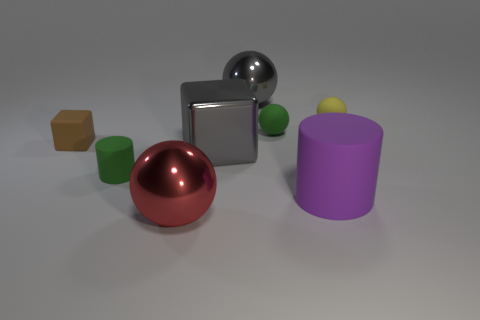Subtract 1 balls. How many balls are left? 3 Subtract all cyan balls. Subtract all green cubes. How many balls are left? 4 Add 1 big blue rubber cylinders. How many objects exist? 9 Subtract all blocks. How many objects are left? 6 Subtract 0 gray cylinders. How many objects are left? 8 Subtract all brown shiny balls. Subtract all yellow rubber things. How many objects are left? 7 Add 4 matte cylinders. How many matte cylinders are left? 6 Add 1 small yellow rubber balls. How many small yellow rubber balls exist? 2 